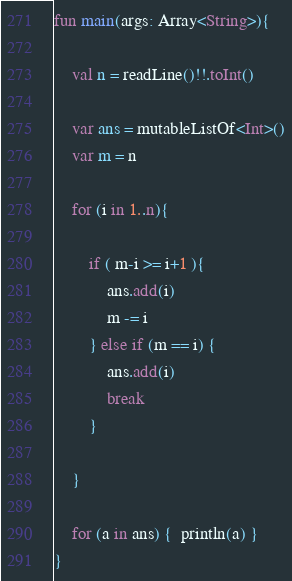<code> <loc_0><loc_0><loc_500><loc_500><_Kotlin_>
fun main(args: Array<String>){
    
    val n = readLine()!!.toInt()

    var ans = mutableListOf<Int>()
    var m = n

    for (i in 1..n){
        
        if ( m-i >= i+1 ){
            ans.add(i)
            m -= i
        } else if (m == i) {
            ans.add(i)
            break
        }

    }

    for (a in ans) {  println(a) }
}</code> 